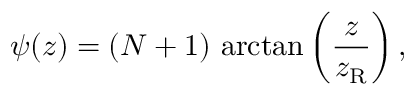<formula> <loc_0><loc_0><loc_500><loc_500>\psi ( z ) = ( N + 1 ) \, \arctan \left ( { \frac { z } { z _ { R } } } \right ) ,</formula> 